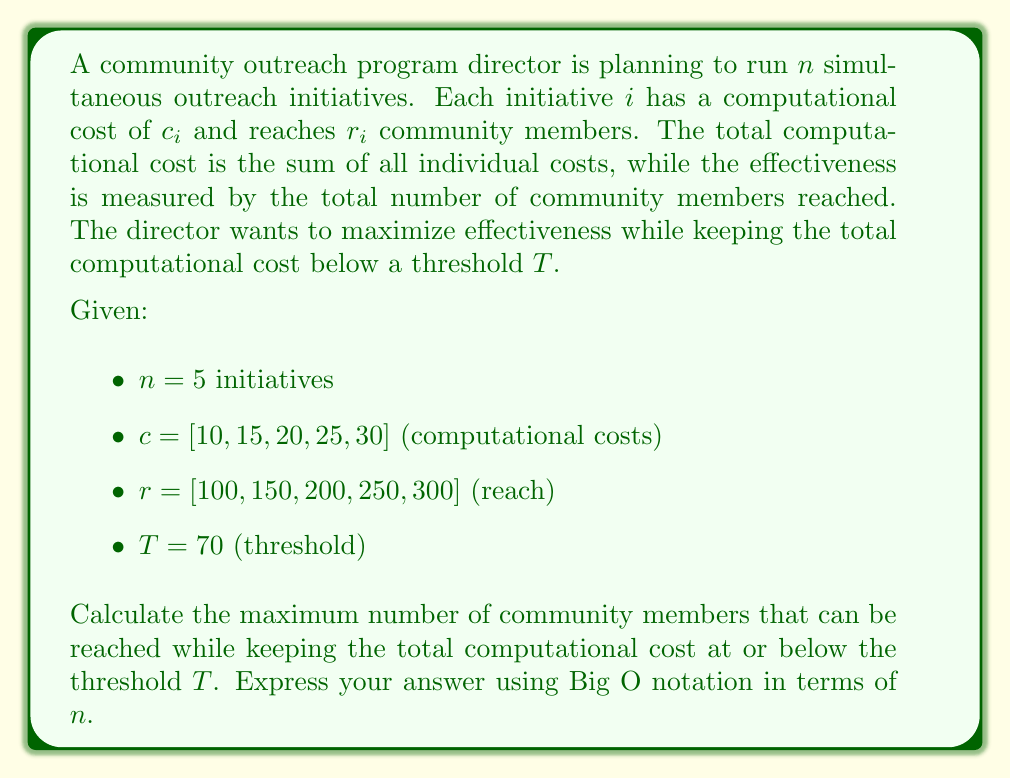Give your solution to this math problem. To solve this problem, we need to use dynamic programming, specifically the 0/1 Knapsack algorithm. Here's a step-by-step explanation:

1) First, we create a 2D array $dp[i][j]$ where $i$ represents the number of initiatives considered (0 to $n$) and $j$ represents the computational cost (0 to $T$).

2) The recurrence relation for this problem is:
   $$dp[i][j] = \max(dp[i-1][j], dp[i-1][j-c[i]] + r[i])$$
   if $j \geq c[i]$, otherwise $dp[i][j] = dp[i-1][j]$

3) We fill this table iteratively, considering each initiative and each possible cost up to $T$.

4) The time complexity of this algorithm is $O(nT)$, where $n$ is the number of initiatives and $T$ is the threshold.

5) The space complexity is also $O(nT)$ for the 2D array.

6) However, we can optimize the space complexity to $O(T)$ by using only two rows of the DP table at a time.

7) In terms of $n$, since $T$ is a constant (70 in this case), the time and space complexities can be expressed as $O(n)$.

8) It's important to note that this is a pseudo-polynomial time algorithm. If $T$ were expressed in binary, the true complexity would be exponential in the input size.

Therefore, the computational complexity of solving this problem, expressed in Big O notation in terms of $n$, is $O(n)$.
Answer: $O(n)$ 